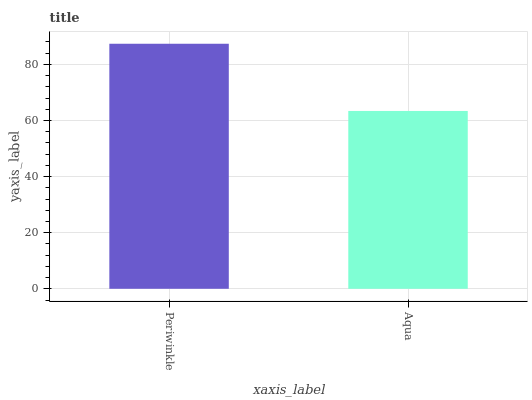Is Aqua the minimum?
Answer yes or no. Yes. Is Periwinkle the maximum?
Answer yes or no. Yes. Is Aqua the maximum?
Answer yes or no. No. Is Periwinkle greater than Aqua?
Answer yes or no. Yes. Is Aqua less than Periwinkle?
Answer yes or no. Yes. Is Aqua greater than Periwinkle?
Answer yes or no. No. Is Periwinkle less than Aqua?
Answer yes or no. No. Is Periwinkle the high median?
Answer yes or no. Yes. Is Aqua the low median?
Answer yes or no. Yes. Is Aqua the high median?
Answer yes or no. No. Is Periwinkle the low median?
Answer yes or no. No. 